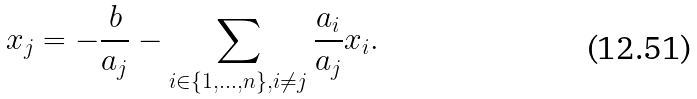<formula> <loc_0><loc_0><loc_500><loc_500>x _ { j } = - { \frac { b } { a _ { j } } } - \sum _ { i \in \{ 1 , \dots , n \} , i \neq j } { \frac { a _ { i } } { a _ { j } } } x _ { i } .</formula> 